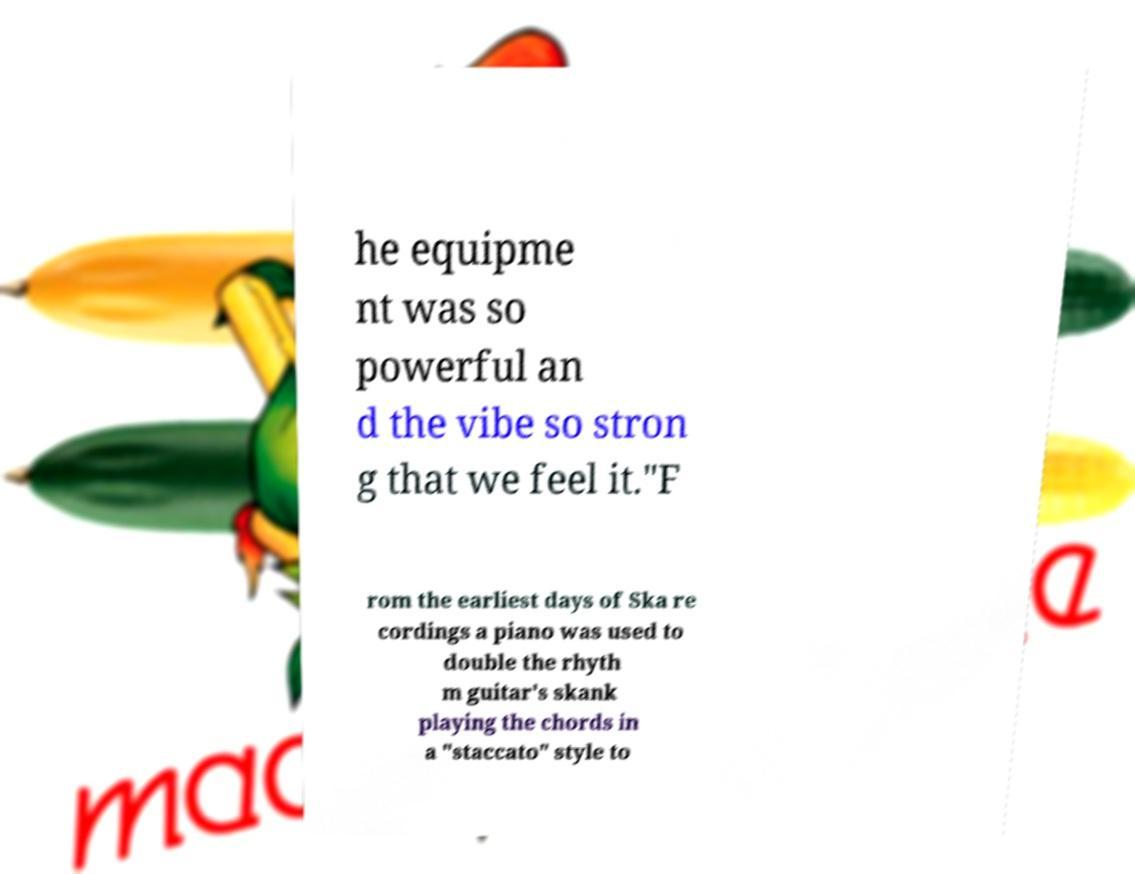Please identify and transcribe the text found in this image. he equipme nt was so powerful an d the vibe so stron g that we feel it."F rom the earliest days of Ska re cordings a piano was used to double the rhyth m guitar's skank playing the chords in a "staccato" style to 